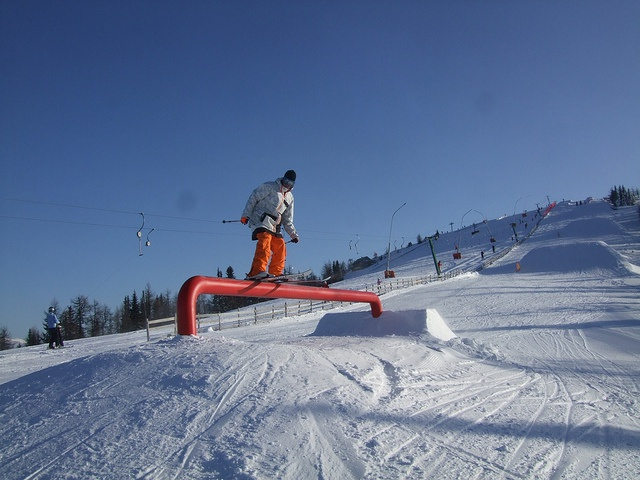Describe the objects in this image and their specific colors. I can see people in darkblue, gray, black, brown, and maroon tones, skis in darkblue, gray, and black tones, people in darkblue, black, navy, and gray tones, and people in darkblue, navy, and gray tones in this image. 